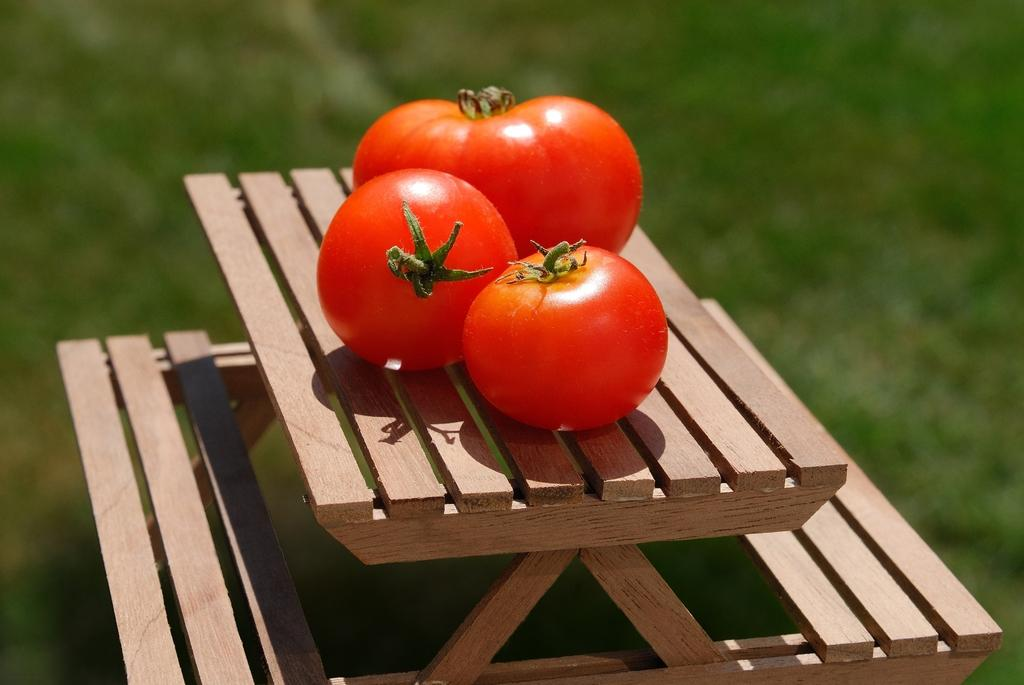What type of furniture is present in the image? There is a picnic table in the image. What mode is the picnic table in? The picnic table is in scale mode. What type of food can be seen on the picnic table? There are three tomatoes on the picnic table. How would you describe the background of the image? The background of the image is blurred. What type of lamp is hanging above the picnic table in the image? There is no lamp present in the image; it only features a picnic table with tomatoes and a blurred background. 